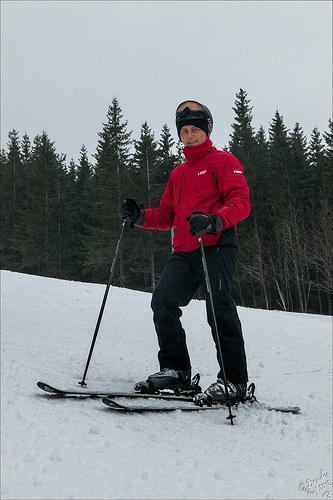How many people are in the photo?
Give a very brief answer. 1. 